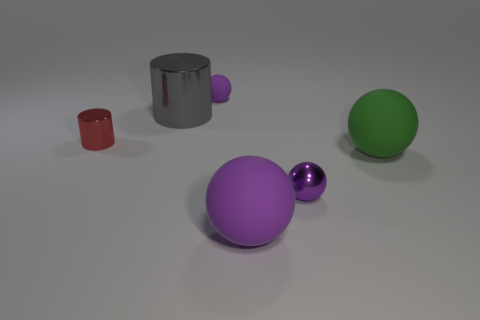Subtract all red blocks. How many purple spheres are left? 3 Add 1 red shiny blocks. How many objects exist? 7 Subtract all balls. How many objects are left? 2 Add 3 big things. How many big things are left? 6 Add 1 purple shiny balls. How many purple shiny balls exist? 2 Subtract 0 red blocks. How many objects are left? 6 Subtract all tiny red metallic things. Subtract all large purple objects. How many objects are left? 4 